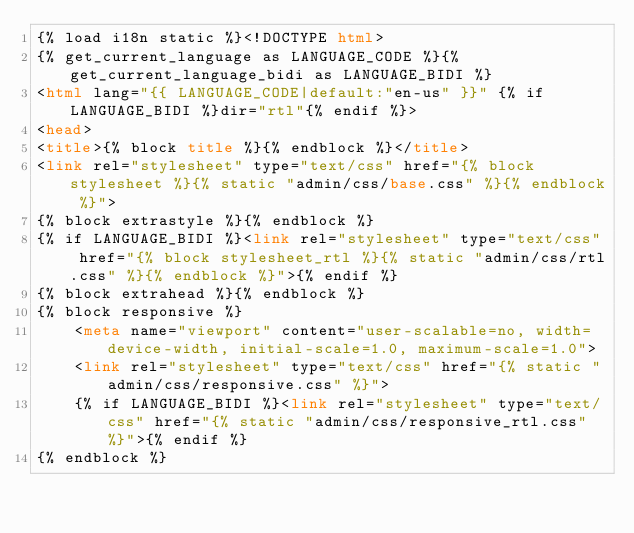<code> <loc_0><loc_0><loc_500><loc_500><_HTML_>{% load i18n static %}<!DOCTYPE html>
{% get_current_language as LANGUAGE_CODE %}{% get_current_language_bidi as LANGUAGE_BIDI %}
<html lang="{{ LANGUAGE_CODE|default:"en-us" }}" {% if LANGUAGE_BIDI %}dir="rtl"{% endif %}>
<head>
<title>{% block title %}{% endblock %}</title>
<link rel="stylesheet" type="text/css" href="{% block stylesheet %}{% static "admin/css/base.css" %}{% endblock %}">
{% block extrastyle %}{% endblock %}
{% if LANGUAGE_BIDI %}<link rel="stylesheet" type="text/css" href="{% block stylesheet_rtl %}{% static "admin/css/rtl.css" %}{% endblock %}">{% endif %}
{% block extrahead %}{% endblock %}
{% block responsive %}
    <meta name="viewport" content="user-scalable=no, width=device-width, initial-scale=1.0, maximum-scale=1.0">
    <link rel="stylesheet" type="text/css" href="{% static "admin/css/responsive.css" %}">
    {% if LANGUAGE_BIDI %}<link rel="stylesheet" type="text/css" href="{% static "admin/css/responsive_rtl.css" %}">{% endif %}
{% endblock %}</code> 